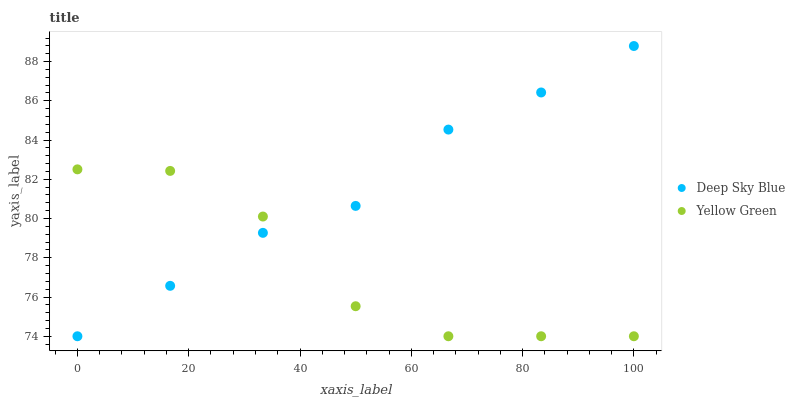Does Yellow Green have the minimum area under the curve?
Answer yes or no. Yes. Does Deep Sky Blue have the maximum area under the curve?
Answer yes or no. Yes. Does Deep Sky Blue have the minimum area under the curve?
Answer yes or no. No. Is Deep Sky Blue the smoothest?
Answer yes or no. Yes. Is Yellow Green the roughest?
Answer yes or no. Yes. Is Deep Sky Blue the roughest?
Answer yes or no. No. Does Yellow Green have the lowest value?
Answer yes or no. Yes. Does Deep Sky Blue have the highest value?
Answer yes or no. Yes. Does Yellow Green intersect Deep Sky Blue?
Answer yes or no. Yes. Is Yellow Green less than Deep Sky Blue?
Answer yes or no. No. Is Yellow Green greater than Deep Sky Blue?
Answer yes or no. No. 